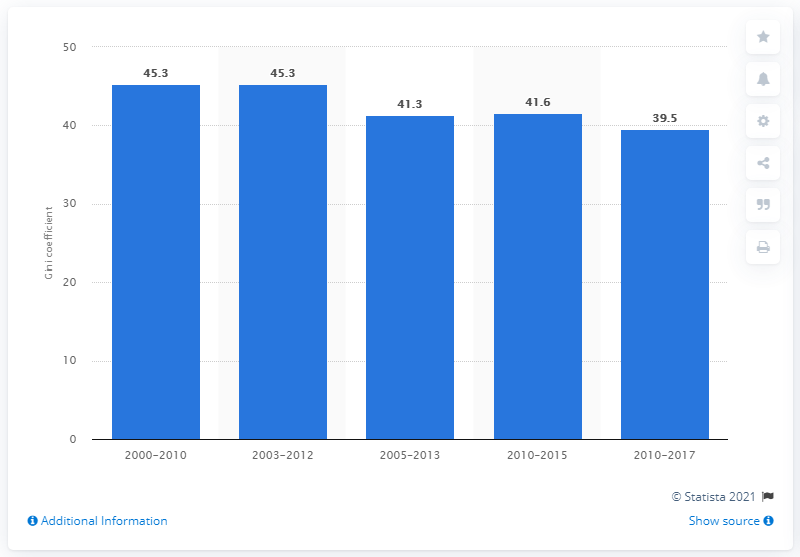Outline some significant characteristics in this image. Uruguay's Gini coefficient in 2017 was 39.5, indicating a moderate level of income inequality in that year. 